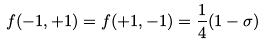Convert formula to latex. <formula><loc_0><loc_0><loc_500><loc_500>f ( - 1 , + 1 ) = f ( + 1 , - 1 ) = { \frac { 1 } { 4 } } ( 1 - \sigma )</formula> 